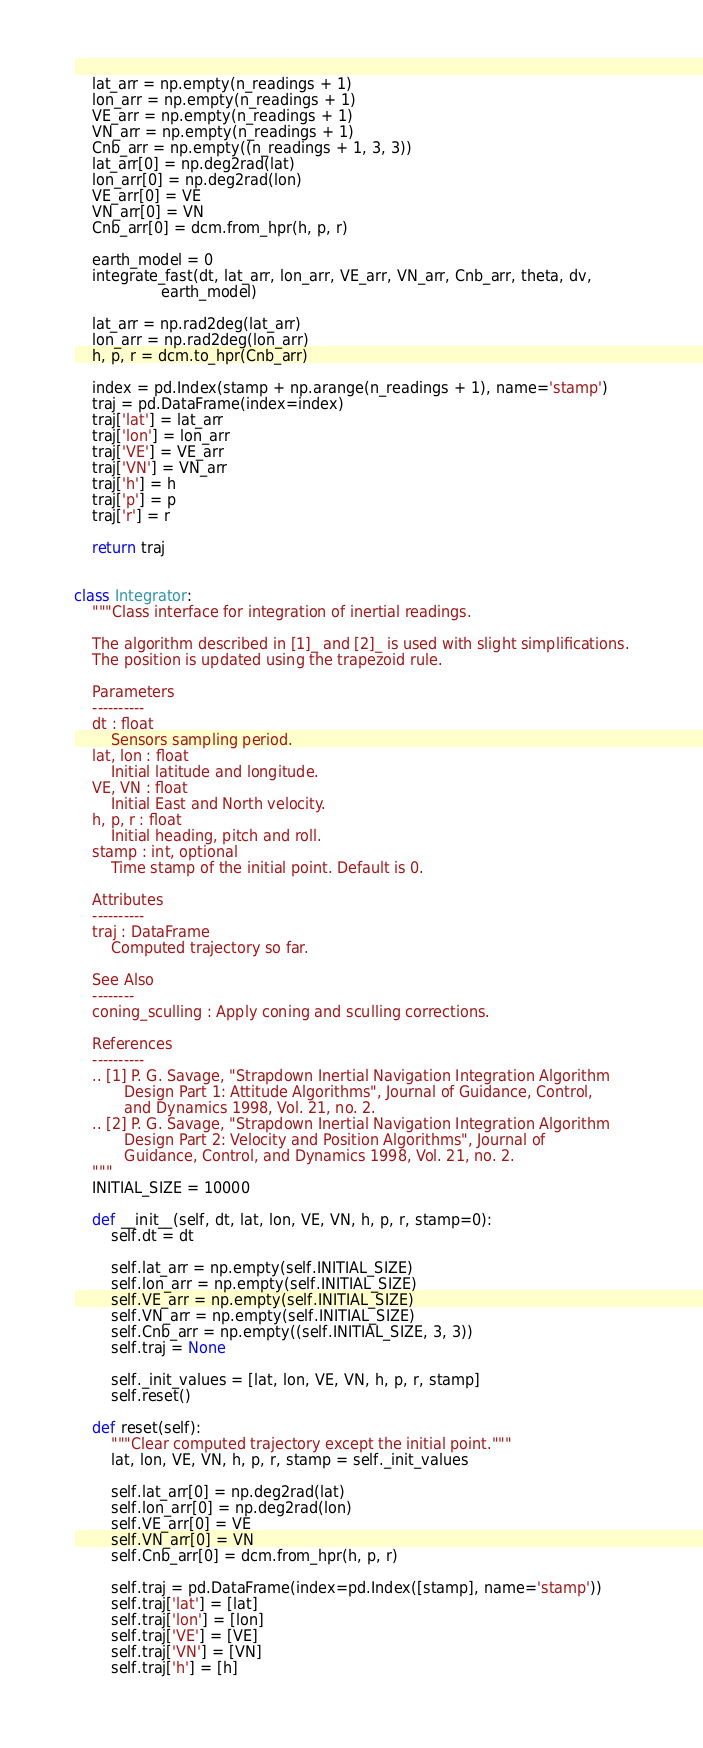<code> <loc_0><loc_0><loc_500><loc_500><_Python_>    lat_arr = np.empty(n_readings + 1)
    lon_arr = np.empty(n_readings + 1)
    VE_arr = np.empty(n_readings + 1)
    VN_arr = np.empty(n_readings + 1)
    Cnb_arr = np.empty((n_readings + 1, 3, 3))
    lat_arr[0] = np.deg2rad(lat)
    lon_arr[0] = np.deg2rad(lon)
    VE_arr[0] = VE
    VN_arr[0] = VN
    Cnb_arr[0] = dcm.from_hpr(h, p, r)

    earth_model = 0
    integrate_fast(dt, lat_arr, lon_arr, VE_arr, VN_arr, Cnb_arr, theta, dv,
                   earth_model)

    lat_arr = np.rad2deg(lat_arr)
    lon_arr = np.rad2deg(lon_arr)
    h, p, r = dcm.to_hpr(Cnb_arr)

    index = pd.Index(stamp + np.arange(n_readings + 1), name='stamp')
    traj = pd.DataFrame(index=index)
    traj['lat'] = lat_arr
    traj['lon'] = lon_arr
    traj['VE'] = VE_arr
    traj['VN'] = VN_arr
    traj['h'] = h
    traj['p'] = p
    traj['r'] = r

    return traj


class Integrator:
    """Class interface for integration of inertial readings.

    The algorithm described in [1]_ and [2]_ is used with slight simplifications.
    The position is updated using the trapezoid rule.

    Parameters
    ----------
    dt : float
        Sensors sampling period.
    lat, lon : float
        Initial latitude and longitude.
    VE, VN : float
        Initial East and North velocity.
    h, p, r : float
        Initial heading, pitch and roll.
    stamp : int, optional
        Time stamp of the initial point. Default is 0.

    Attributes
    ----------
    traj : DataFrame
        Computed trajectory so far.

    See Also
    --------
    coning_sculling : Apply coning and sculling corrections.

    References
    ----------
    .. [1] P. G. Savage, "Strapdown Inertial Navigation Integration Algorithm
           Design Part 1: Attitude Algorithms", Journal of Guidance, Control,
           and Dynamics 1998, Vol. 21, no. 2.
    .. [2] P. G. Savage, "Strapdown Inertial Navigation Integration Algorithm
           Design Part 2: Velocity and Position Algorithms", Journal of
           Guidance, Control, and Dynamics 1998, Vol. 21, no. 2.
    """
    INITIAL_SIZE = 10000

    def __init__(self, dt, lat, lon, VE, VN, h, p, r, stamp=0):
        self.dt = dt

        self.lat_arr = np.empty(self.INITIAL_SIZE)
        self.lon_arr = np.empty(self.INITIAL_SIZE)
        self.VE_arr = np.empty(self.INITIAL_SIZE)
        self.VN_arr = np.empty(self.INITIAL_SIZE)
        self.Cnb_arr = np.empty((self.INITIAL_SIZE, 3, 3))
        self.traj = None

        self._init_values = [lat, lon, VE, VN, h, p, r, stamp]
        self.reset()

    def reset(self):
        """Clear computed trajectory except the initial point."""
        lat, lon, VE, VN, h, p, r, stamp = self._init_values

        self.lat_arr[0] = np.deg2rad(lat)
        self.lon_arr[0] = np.deg2rad(lon)
        self.VE_arr[0] = VE
        self.VN_arr[0] = VN
        self.Cnb_arr[0] = dcm.from_hpr(h, p, r)

        self.traj = pd.DataFrame(index=pd.Index([stamp], name='stamp'))
        self.traj['lat'] = [lat]
        self.traj['lon'] = [lon]
        self.traj['VE'] = [VE]
        self.traj['VN'] = [VN]
        self.traj['h'] = [h]</code> 